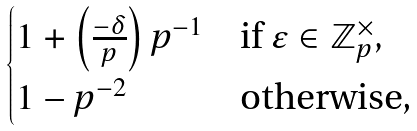Convert formula to latex. <formula><loc_0><loc_0><loc_500><loc_500>\begin{cases} 1 + \left ( \frac { - \delta } { p } \right ) p ^ { - 1 } & \text {if } \varepsilon \in \mathbb { Z } _ { p } ^ { \times } , \\ 1 - p ^ { - 2 } & \text {otherwise,} \end{cases}</formula> 